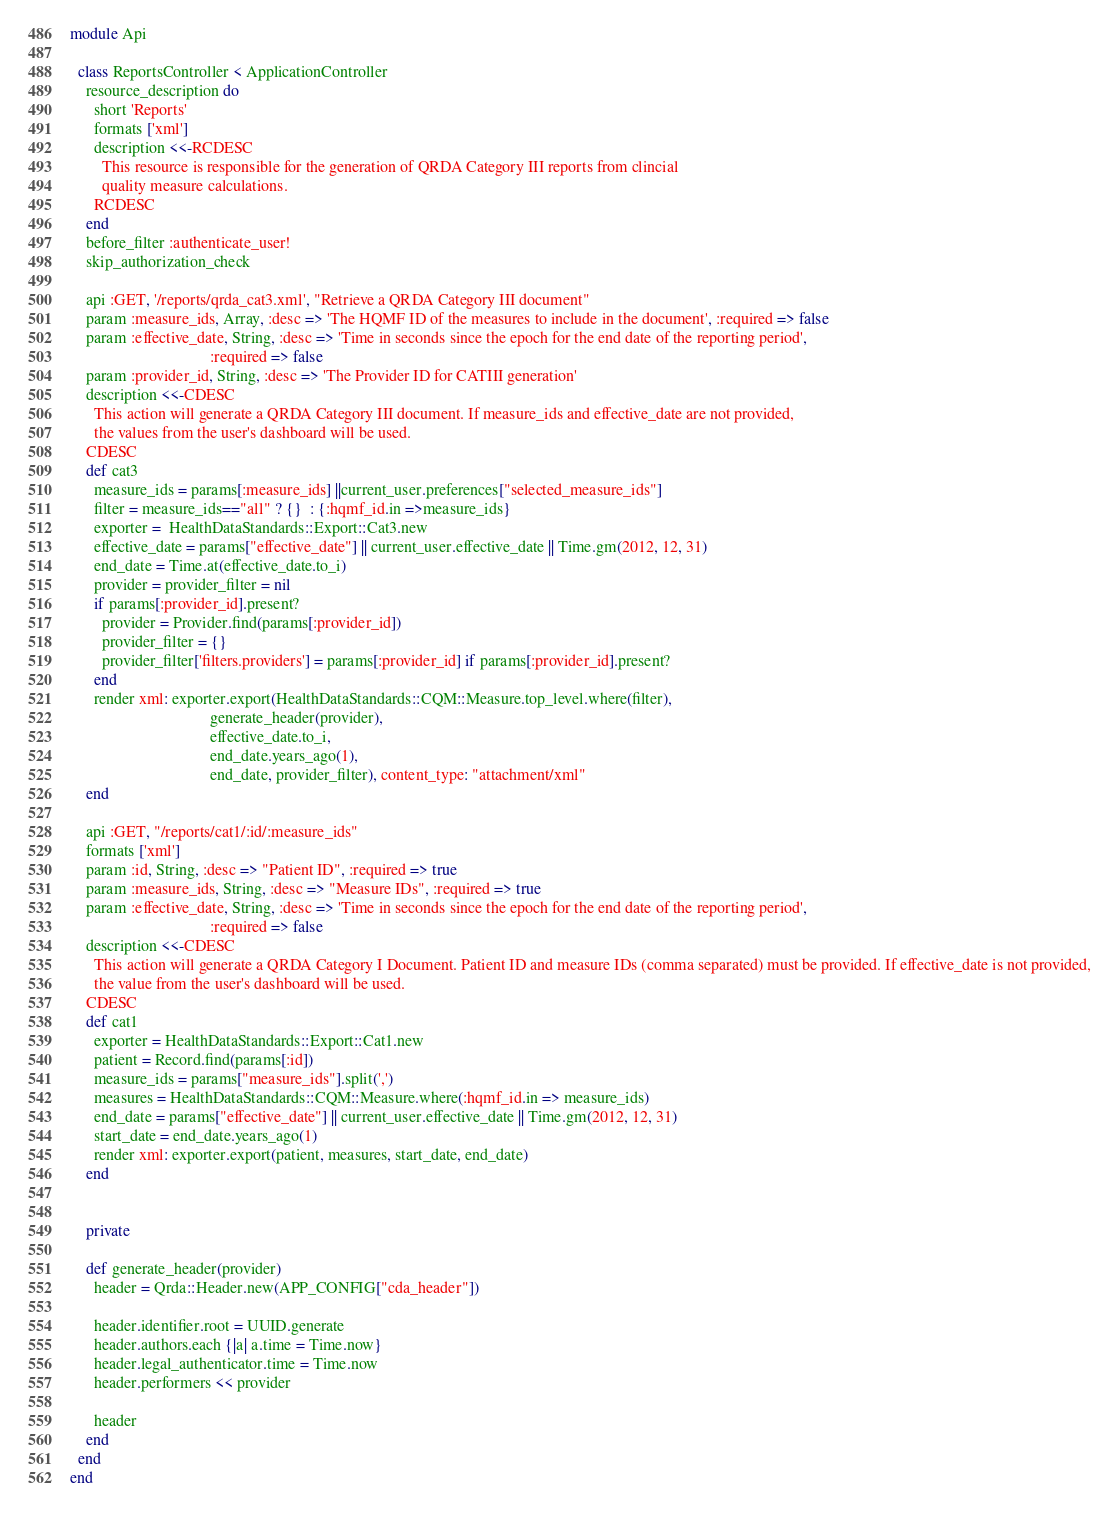Convert code to text. <code><loc_0><loc_0><loc_500><loc_500><_Ruby_>module Api

  class ReportsController < ApplicationController
    resource_description do
      short 'Reports'
      formats ['xml']
      description <<-RCDESC
        This resource is responsible for the generation of QRDA Category III reports from clincial
        quality measure calculations.
      RCDESC
    end
    before_filter :authenticate_user!
    skip_authorization_check

    api :GET, '/reports/qrda_cat3.xml', "Retrieve a QRDA Category III document"
    param :measure_ids, Array, :desc => 'The HQMF ID of the measures to include in the document', :required => false
    param :effective_date, String, :desc => 'Time in seconds since the epoch for the end date of the reporting period',
                                   :required => false
    param :provider_id, String, :desc => 'The Provider ID for CATIII generation'
    description <<-CDESC
      This action will generate a QRDA Category III document. If measure_ids and effective_date are not provided,
      the values from the user's dashboard will be used.
    CDESC
    def cat3
      measure_ids = params[:measure_ids] ||current_user.preferences["selected_measure_ids"]
      filter = measure_ids=="all" ? {}  : {:hqmf_id.in =>measure_ids}
      exporter =  HealthDataStandards::Export::Cat3.new
      effective_date = params["effective_date"] || current_user.effective_date || Time.gm(2012, 12, 31)
      end_date = Time.at(effective_date.to_i)
      provider = provider_filter = nil
      if params[:provider_id].present?
        provider = Provider.find(params[:provider_id])
        provider_filter = {}
        provider_filter['filters.providers'] = params[:provider_id] if params[:provider_id].present?
      end
      render xml: exporter.export(HealthDataStandards::CQM::Measure.top_level.where(filter),
                                   generate_header(provider),
                                   effective_date.to_i,
                                   end_date.years_ago(1),
                                   end_date, provider_filter), content_type: "attachment/xml"
    end

    api :GET, "/reports/cat1/:id/:measure_ids"
    formats ['xml']
    param :id, String, :desc => "Patient ID", :required => true
    param :measure_ids, String, :desc => "Measure IDs", :required => true
    param :effective_date, String, :desc => 'Time in seconds since the epoch for the end date of the reporting period',
                                   :required => false
    description <<-CDESC
      This action will generate a QRDA Category I Document. Patient ID and measure IDs (comma separated) must be provided. If effective_date is not provided,
      the value from the user's dashboard will be used.
    CDESC
    def cat1
      exporter = HealthDataStandards::Export::Cat1.new
      patient = Record.find(params[:id])
      measure_ids = params["measure_ids"].split(',')
      measures = HealthDataStandards::CQM::Measure.where(:hqmf_id.in => measure_ids)
      end_date = params["effective_date"] || current_user.effective_date || Time.gm(2012, 12, 31)
      start_date = end_date.years_ago(1)
      render xml: exporter.export(patient, measures, start_date, end_date)
    end


    private

    def generate_header(provider)
      header = Qrda::Header.new(APP_CONFIG["cda_header"])

      header.identifier.root = UUID.generate
      header.authors.each {|a| a.time = Time.now}
      header.legal_authenticator.time = Time.now
      header.performers << provider

      header
    end
  end
end
</code> 